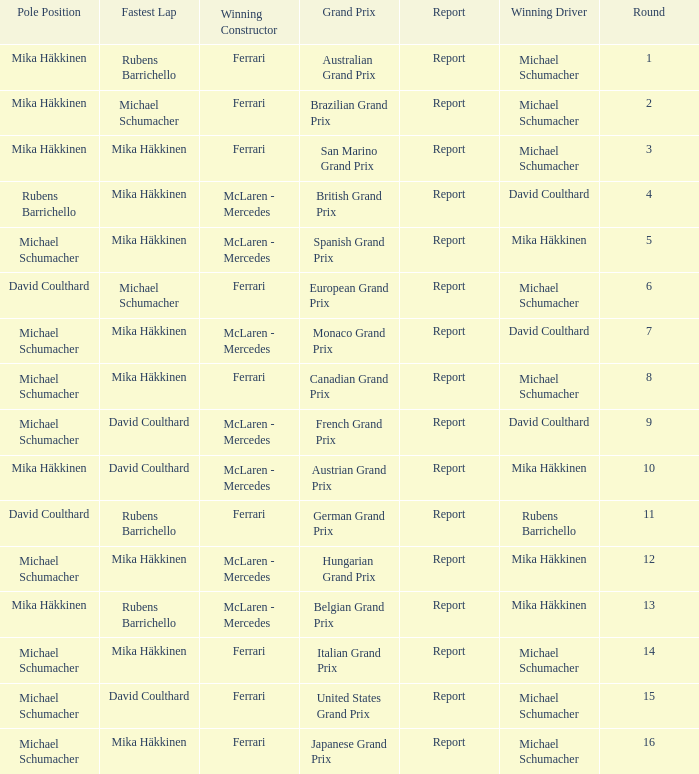Who had the fastest lap in the Belgian Grand Prix? Rubens Barrichello. 